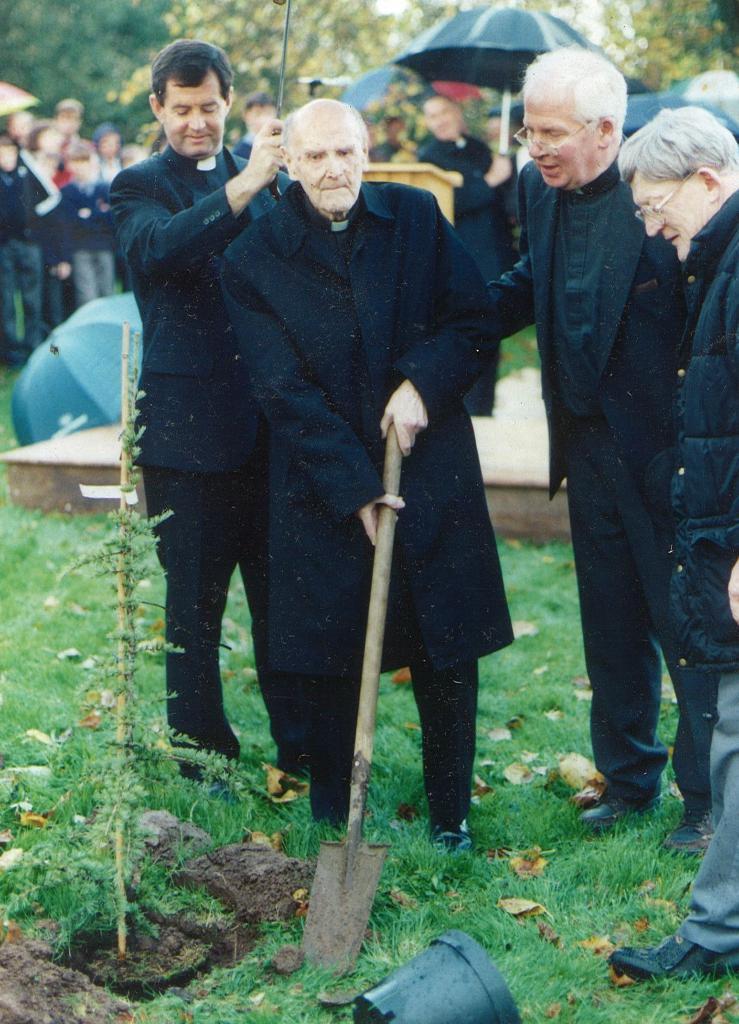Describe this image in one or two sentences. In this picture there are people standing, among them there is a man holding a tool and we can see plant, soil, grass and black object. In the background of the image it is blurry and we can see people, umbrellas and trees. 